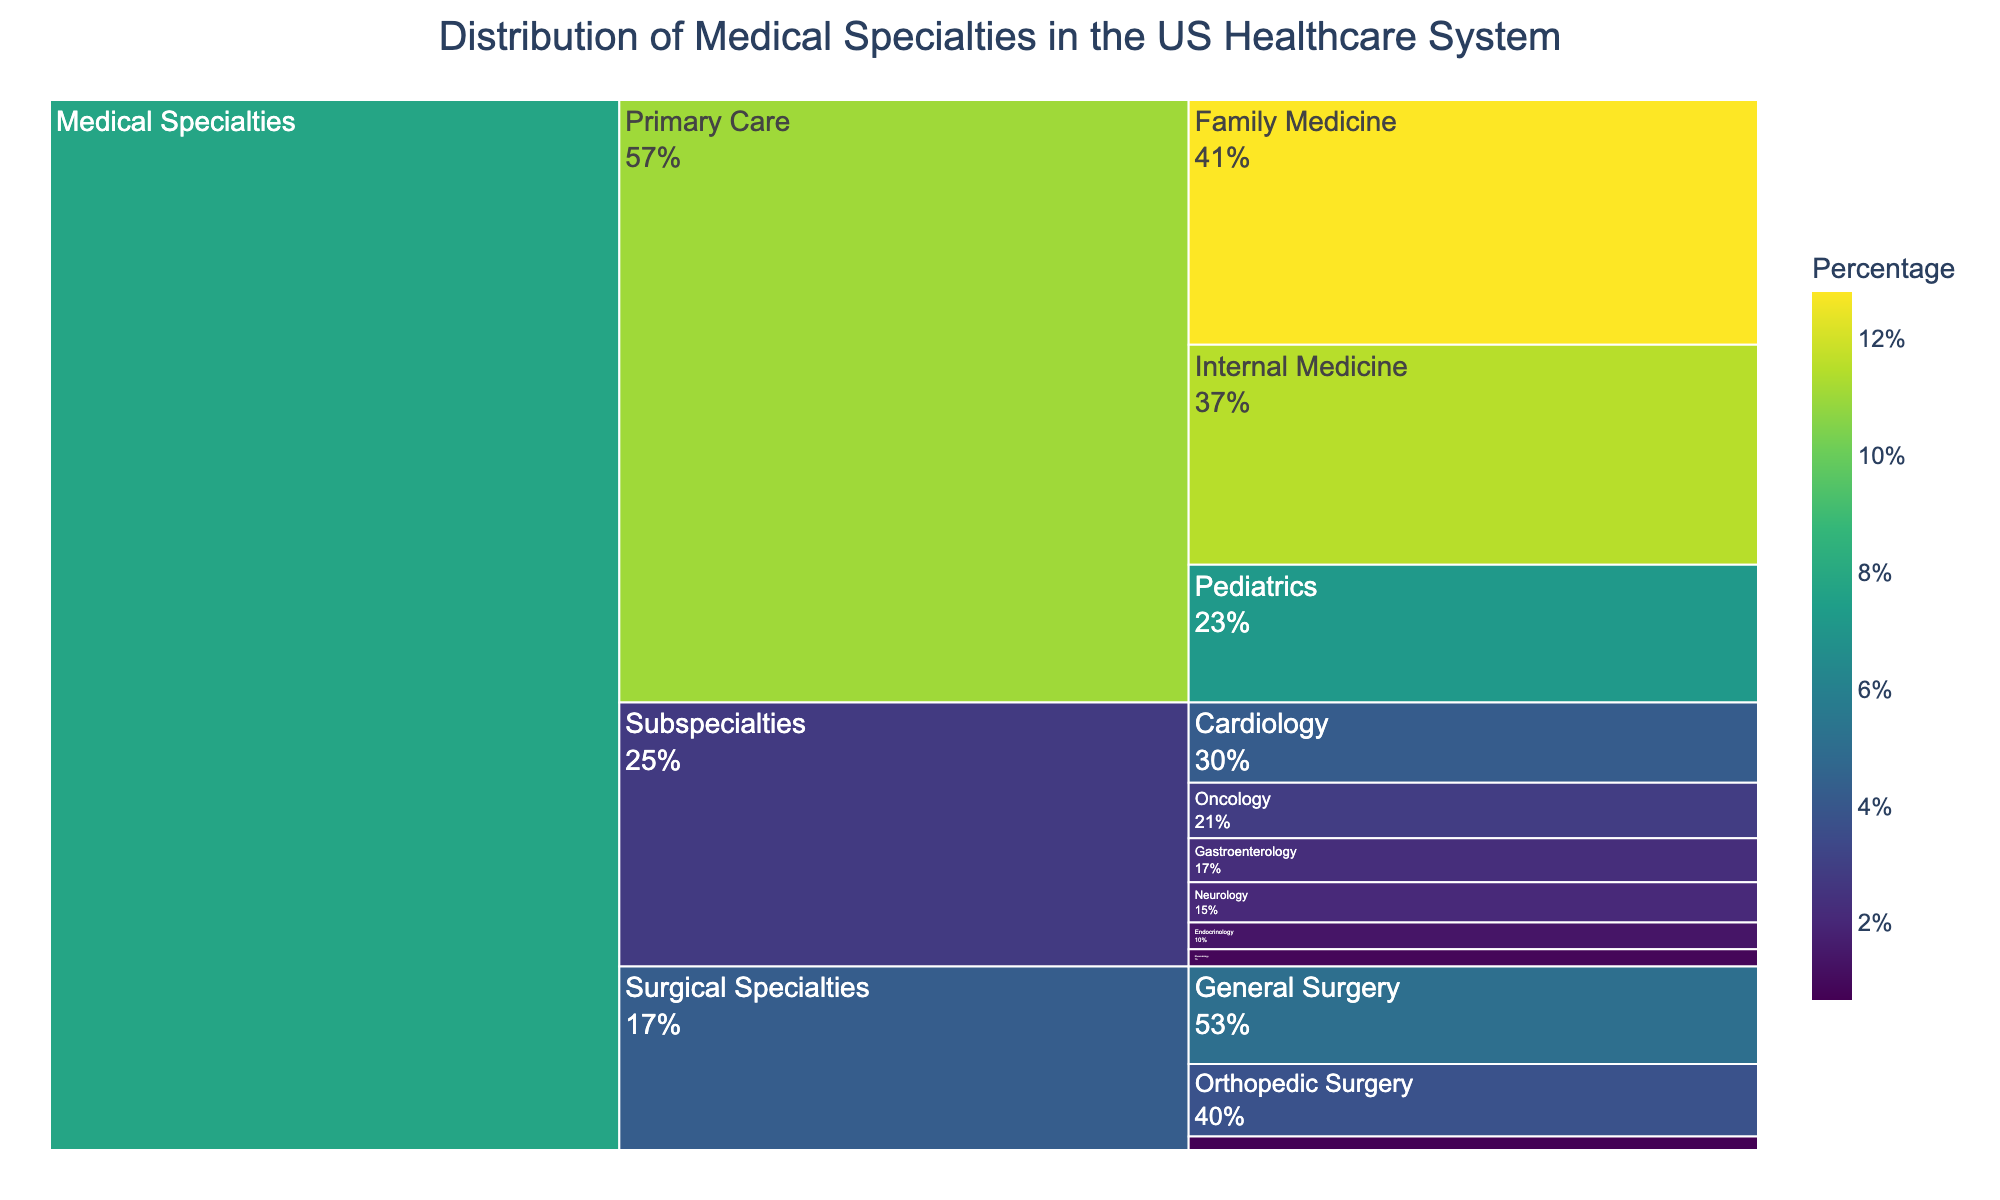What's the percentage of Family Medicine within the Primary Care category? Family Medicine is a subcategory under Primary Care in the icicle chart. The value indicated for Family Medicine is 12.8%
Answer: 12.8% What is the combined percentage for Internal Medicine and Pediatrics? Locate the percentages for Internal Medicine (11.5%) and Pediatrics (7.2%) under Primary Care. Add these percentages: 11.5% + 7.2% = 18.7%
Answer: 18.7% Which specialty has the lowest percentage among the Surgical Specialties? Under the section "Surgical Specialties," compare the percentages. Neurosurgery has the lowest percentage at 0.7%
Answer: Neurosurgery How does the percentage of General Surgery compare to Orthopedic Surgery? Looking under Surgical Specialties, General Surgery is 5.1% and Orthopedic Surgery is 3.8%. General Surgery's percentage is greater.
Answer: General Surgery What is the total percentage for Subspecialties? Add the percentages of all specialties under Subspecialties: Cardiology (4.2%), Oncology (2.9%), Endocrinology (1.4%), Gastroenterology (2.3%), Neurology (2.1%), and Rheumatology (0.9%). The sum is 4.2% + 2.9% + 1.4% + 2.3% + 2.1% + 0.9% = 13.8%
Answer: 13.8% Which specialty under Subspecialties has the highest percentage? Within Subspecialties, compare the percentages. Cardiology has the highest percentage at 4.2%
Answer: Cardiology What is the relationship between Oncology and Gastroenterology in terms of percentage? Oncology is 2.9% and Gastroenterology is 2.3%. Oncology's percentage is higher than Gastroenterology's
Answer: Oncology How does the total percentage of Primary Care compare to Surgical Specialties? Add all specialties under Primary Care: Family Medicine (12.8%), Internal Medicine (11.5%), and Pediatrics (7.2%). The total is 12.8% + 11.5% + 7.2% = 31.5%. For Surgical Specialties: General Surgery (5.1%), Orthopedic Surgery (3.8%), Neurosurgery (0.7%). The total is 5.1% + 3.8% + 0.7% = 9.6%. Primary Care has a higher total percentage.
Answer: Primary Care What's the percentage difference between Neurology and Rheumatology within Subspecialties? Neurology has a percentage of 2.1% and Rheumatology has a percentage of 0.9%. The difference is 2.1% - 0.9% = 1.2%
Answer: 1.2% 